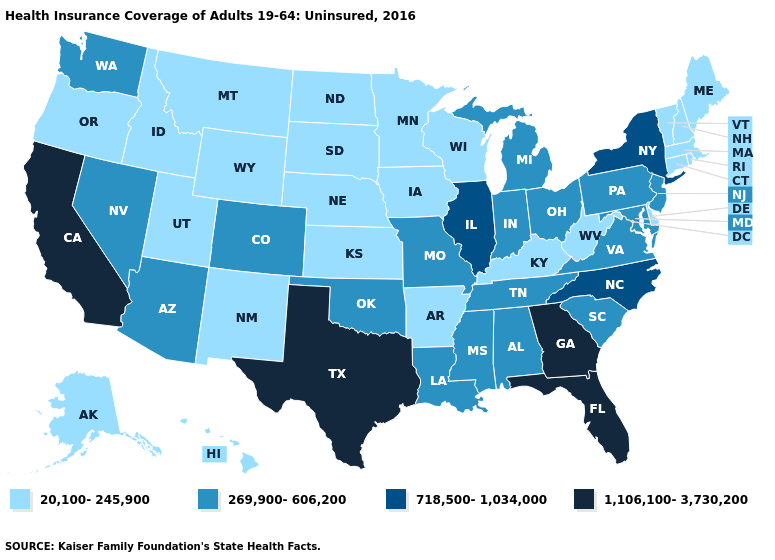Does Illinois have the highest value in the MidWest?
Be succinct. Yes. How many symbols are there in the legend?
Write a very short answer. 4. What is the value of North Dakota?
Write a very short answer. 20,100-245,900. Does Louisiana have the same value as Montana?
Quick response, please. No. Does the first symbol in the legend represent the smallest category?
Write a very short answer. Yes. Name the states that have a value in the range 718,500-1,034,000?
Write a very short answer. Illinois, New York, North Carolina. How many symbols are there in the legend?
Quick response, please. 4. What is the lowest value in the USA?
Give a very brief answer. 20,100-245,900. Does the map have missing data?
Answer briefly. No. How many symbols are there in the legend?
Write a very short answer. 4. What is the value of Massachusetts?
Be succinct. 20,100-245,900. Name the states that have a value in the range 20,100-245,900?
Quick response, please. Alaska, Arkansas, Connecticut, Delaware, Hawaii, Idaho, Iowa, Kansas, Kentucky, Maine, Massachusetts, Minnesota, Montana, Nebraska, New Hampshire, New Mexico, North Dakota, Oregon, Rhode Island, South Dakota, Utah, Vermont, West Virginia, Wisconsin, Wyoming. Among the states that border Michigan , does Ohio have the lowest value?
Be succinct. No. What is the value of Kentucky?
Write a very short answer. 20,100-245,900. Name the states that have a value in the range 718,500-1,034,000?
Concise answer only. Illinois, New York, North Carolina. 